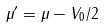Convert formula to latex. <formula><loc_0><loc_0><loc_500><loc_500>\mu ^ { \prime } = \mu - V _ { 0 } / 2</formula> 